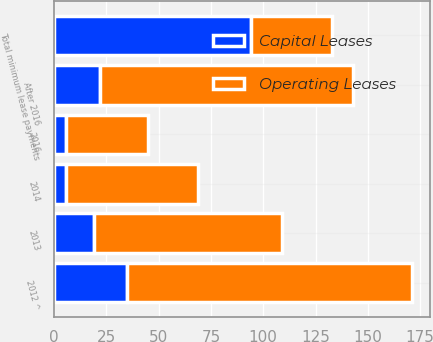Convert chart. <chart><loc_0><loc_0><loc_500><loc_500><stacked_bar_chart><ecel><fcel>2012 ^<fcel>2013<fcel>2014<fcel>2016<fcel>After 2016<fcel>Total minimum lease payments<nl><fcel>Capital Leases<fcel>35<fcel>19<fcel>6<fcel>6<fcel>22<fcel>94<nl><fcel>Operating Leases<fcel>136<fcel>90<fcel>63<fcel>39<fcel>121<fcel>39<nl></chart> 